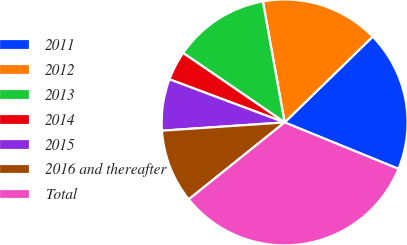<chart> <loc_0><loc_0><loc_500><loc_500><pie_chart><fcel>2011<fcel>2012<fcel>2013<fcel>2014<fcel>2015<fcel>2016 and thereafter<fcel>Total<nl><fcel>18.46%<fcel>15.54%<fcel>12.62%<fcel>3.85%<fcel>6.77%<fcel>9.69%<fcel>33.07%<nl></chart> 